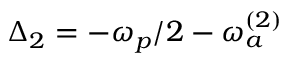<formula> <loc_0><loc_0><loc_500><loc_500>\Delta _ { 2 } = - \omega _ { p } / 2 - \omega _ { a } ^ { ( 2 ) }</formula> 